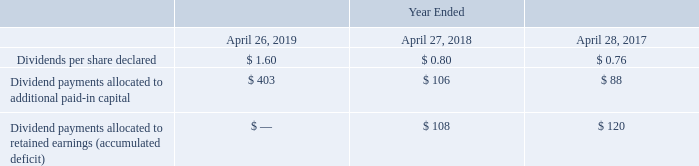Dividends
The following is a summary of our fiscal 2019, 2018 and 2017 activities related to dividends on our common stock (in millions, except per share amounts).
On May 22, 2019, we declared a cash dividend of $0.48 per share of common stock, payable on July 24, 2019 to shareholders of record as of the close of business on July 5, 2019. The timing and amount of future dividends will depend on market conditions, corporate business and financial considerations and regulatory requirements. All dividends declared have been determined by the Company to be legally authorized under the laws of the state in which we are incorporated.
What did the company declare regarding dividends? A cash dividend of $0.48 per share of common stock, payable on july 24, 2019 to shareholders of record as of the close of business on july 5, 2019. Which years does the table provide information for? 2019, 2018, 2017. What do the timing and amount of future dividends depend on? Market conditions, corporate business and financial considerations and regulatory requirements. What was the change in the Dividends per share declared between 2018 and 2019? 1.60-0.80
Answer: 0.8. What was the change in the Dividend payments allocated to retained earnings (accumulated deficit) between 2017 and 2018?
Answer scale should be: million. 108-120
Answer: -12. What was the percentage change in the Dividend payments allocated to additional paid-in capital between 2017 and 2018?
Answer scale should be: percent. (106-88)/88
Answer: 20.45. 